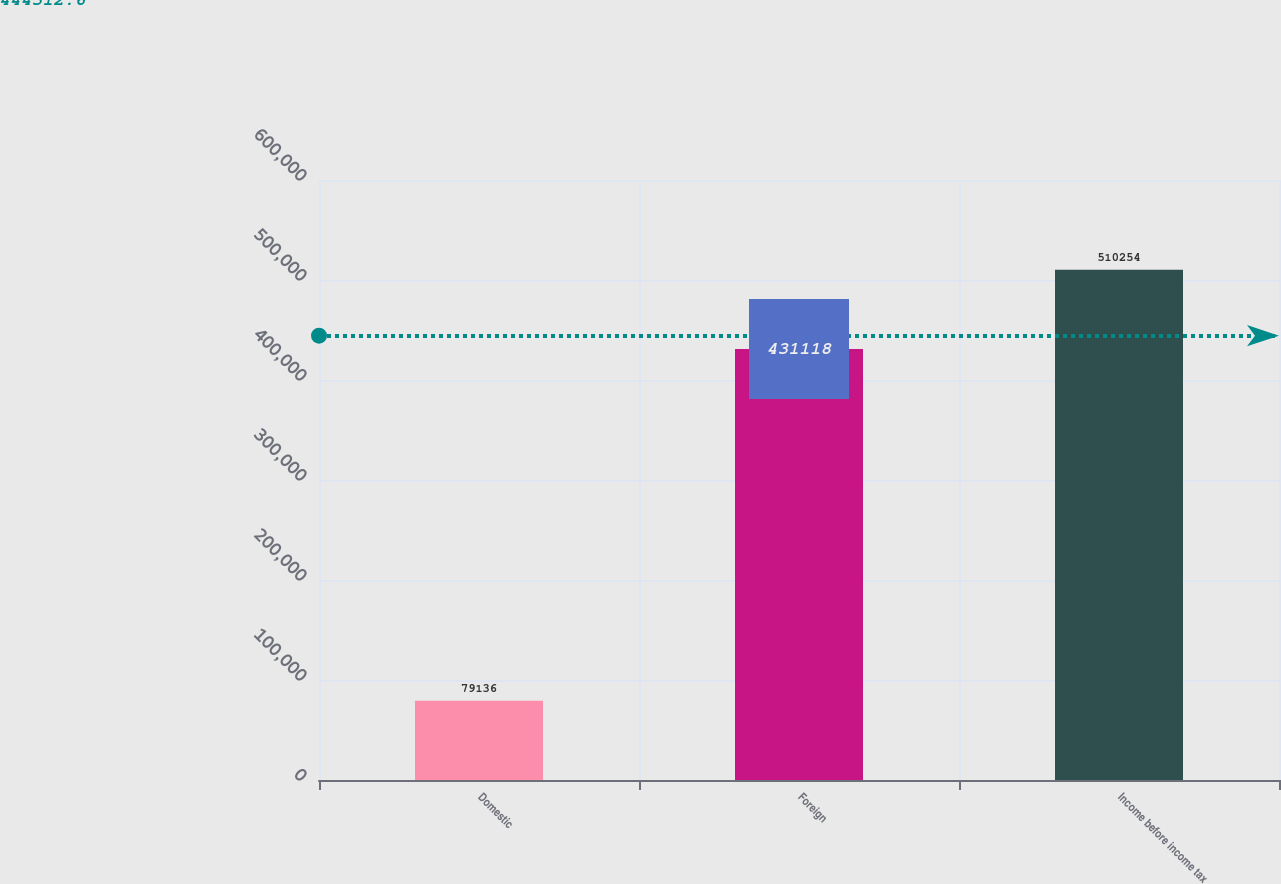Convert chart to OTSL. <chart><loc_0><loc_0><loc_500><loc_500><bar_chart><fcel>Domestic<fcel>Foreign<fcel>Income before income tax<nl><fcel>79136<fcel>431118<fcel>510254<nl></chart> 